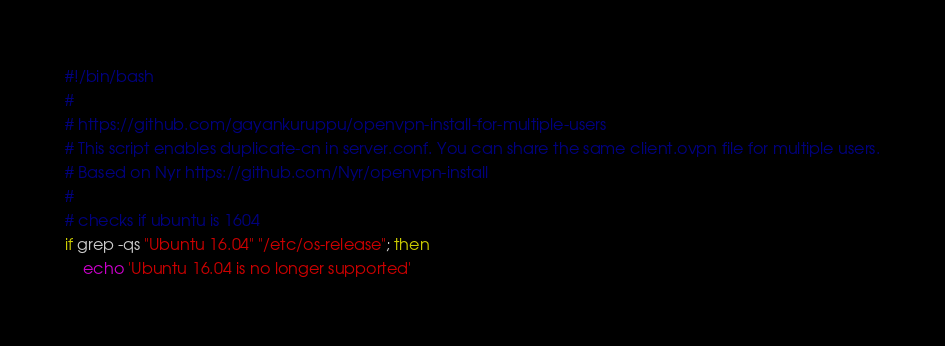Convert code to text. <code><loc_0><loc_0><loc_500><loc_500><_Bash_>#!/bin/bash
#
# https://github.com/gayankuruppu/openvpn-install-for-multiple-users
# This script enables duplicate-cn in server.conf. You can share the same client.ovpn file for multiple users.
# Based on Nyr https://github.com/Nyr/openvpn-install
#
# checks if ubuntu is 1604
if grep -qs "Ubuntu 16.04" "/etc/os-release"; then
	echo 'Ubuntu 16.04 is no longer supported'</code> 